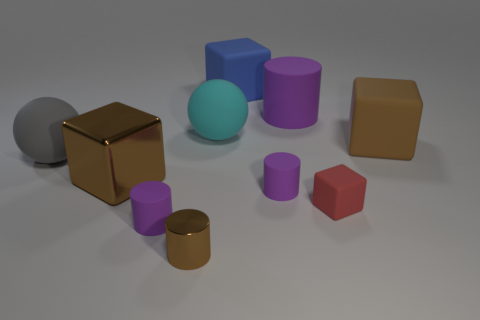Subtract all red blocks. How many purple cylinders are left? 3 Subtract 1 cylinders. How many cylinders are left? 3 Subtract all brown cylinders. How many cylinders are left? 3 Subtract all red cylinders. Subtract all brown cubes. How many cylinders are left? 4 Subtract all cylinders. How many objects are left? 6 Subtract all tiny red rubber things. Subtract all cyan balls. How many objects are left? 8 Add 7 rubber cylinders. How many rubber cylinders are left? 10 Add 6 large cyan matte spheres. How many large cyan matte spheres exist? 7 Subtract 0 purple spheres. How many objects are left? 10 